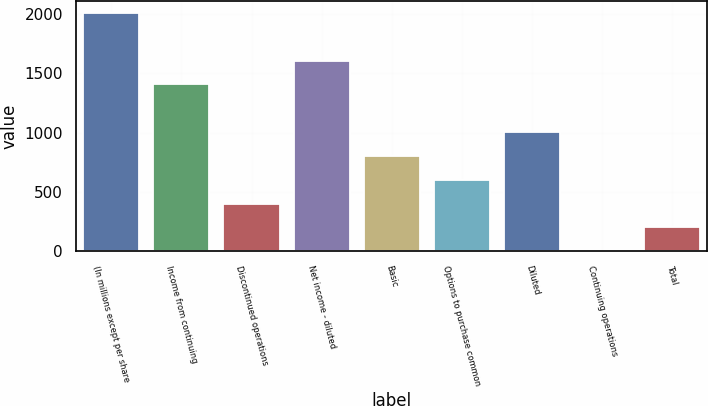<chart> <loc_0><loc_0><loc_500><loc_500><bar_chart><fcel>(In millions except per share<fcel>Income from continuing<fcel>Discontinued operations<fcel>Net income - diluted<fcel>Basic<fcel>Options to purchase common<fcel>Diluted<fcel>Continuing operations<fcel>Total<nl><fcel>2006<fcel>1404.96<fcel>403.16<fcel>1605.32<fcel>803.88<fcel>603.52<fcel>1004.24<fcel>2.44<fcel>202.8<nl></chart> 